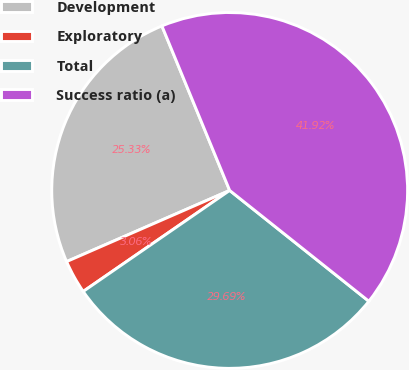Convert chart. <chart><loc_0><loc_0><loc_500><loc_500><pie_chart><fcel>Development<fcel>Exploratory<fcel>Total<fcel>Success ratio (a)<nl><fcel>25.33%<fcel>3.06%<fcel>29.69%<fcel>41.92%<nl></chart> 